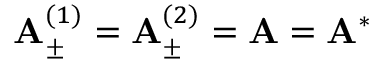<formula> <loc_0><loc_0><loc_500><loc_500>{ A } _ { \pm } ^ { ( 1 ) } = { A } _ { \pm } ^ { ( 2 ) } = { A } = { A } ^ { * }</formula> 